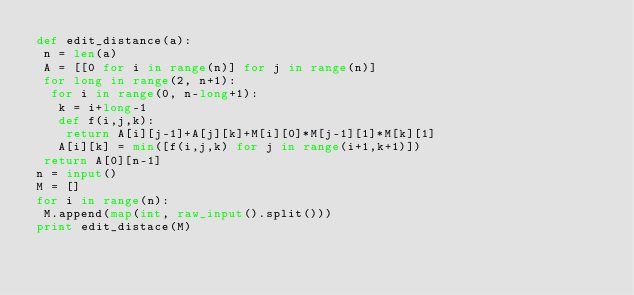Convert code to text. <code><loc_0><loc_0><loc_500><loc_500><_Python_>def edit_distance(a):
 n = len(a)
 A = [[0 for i in range(n)] for j in range(n)]
 for long in range(2, n+1):
  for i in range(0, n-long+1):
   k = i+long-1
   def f(i,j,k):
    return A[i][j-1]+A[j][k]+M[i][0]*M[j-1][1]*M[k][1]
   A[i][k] = min([f(i,j,k) for j in range(i+1,k+1)])
 return A[0][n-1]
n = input()
M = []
for i in range(n):
 M.append(map(int, raw_input().split()))
print edit_distace(M)
 </code> 